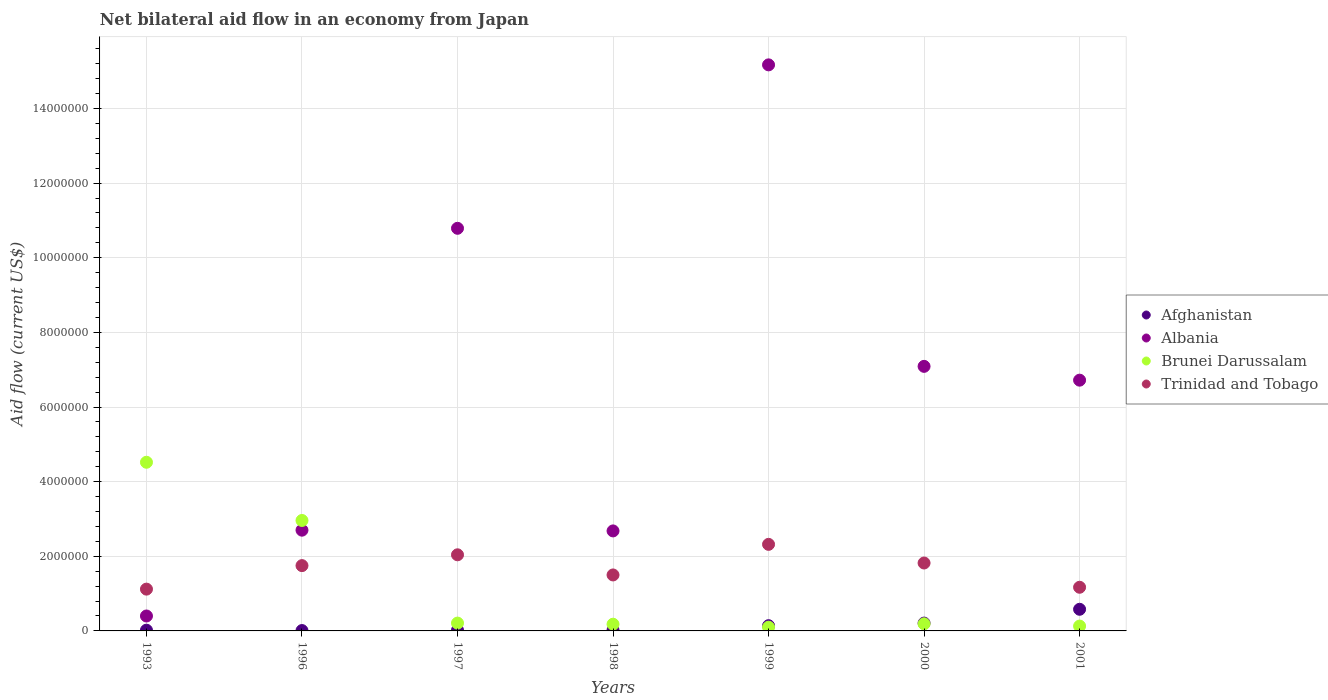How many different coloured dotlines are there?
Offer a terse response. 4. What is the net bilateral aid flow in Albania in 1998?
Make the answer very short. 2.68e+06. Across all years, what is the maximum net bilateral aid flow in Afghanistan?
Your response must be concise. 5.80e+05. In which year was the net bilateral aid flow in Trinidad and Tobago maximum?
Provide a short and direct response. 1999. In which year was the net bilateral aid flow in Trinidad and Tobago minimum?
Your answer should be compact. 1993. What is the total net bilateral aid flow in Afghanistan in the graph?
Give a very brief answer. 1.00e+06. What is the difference between the net bilateral aid flow in Albania in 1993 and that in 2001?
Provide a succinct answer. -6.32e+06. What is the difference between the net bilateral aid flow in Albania in 1999 and the net bilateral aid flow in Afghanistan in 1996?
Give a very brief answer. 1.52e+07. What is the average net bilateral aid flow in Trinidad and Tobago per year?
Keep it short and to the point. 1.67e+06. In the year 1997, what is the difference between the net bilateral aid flow in Trinidad and Tobago and net bilateral aid flow in Afghanistan?
Your answer should be compact. 2.02e+06. In how many years, is the net bilateral aid flow in Trinidad and Tobago greater than 4400000 US$?
Provide a succinct answer. 0. What is the ratio of the net bilateral aid flow in Brunei Darussalam in 1997 to that in 1999?
Give a very brief answer. 2.1. Is the net bilateral aid flow in Afghanistan in 1993 less than that in 1996?
Provide a succinct answer. No. Is the difference between the net bilateral aid flow in Trinidad and Tobago in 1998 and 2001 greater than the difference between the net bilateral aid flow in Afghanistan in 1998 and 2001?
Offer a very short reply. Yes. What is the difference between the highest and the second highest net bilateral aid flow in Afghanistan?
Offer a very short reply. 3.70e+05. What is the difference between the highest and the lowest net bilateral aid flow in Brunei Darussalam?
Offer a terse response. 4.42e+06. Is the sum of the net bilateral aid flow in Trinidad and Tobago in 1998 and 2000 greater than the maximum net bilateral aid flow in Albania across all years?
Ensure brevity in your answer.  No. Is it the case that in every year, the sum of the net bilateral aid flow in Albania and net bilateral aid flow in Brunei Darussalam  is greater than the sum of net bilateral aid flow in Afghanistan and net bilateral aid flow in Trinidad and Tobago?
Make the answer very short. Yes. Is it the case that in every year, the sum of the net bilateral aid flow in Brunei Darussalam and net bilateral aid flow in Albania  is greater than the net bilateral aid flow in Trinidad and Tobago?
Give a very brief answer. Yes. Does the net bilateral aid flow in Trinidad and Tobago monotonically increase over the years?
Offer a very short reply. No. Is the net bilateral aid flow in Trinidad and Tobago strictly less than the net bilateral aid flow in Afghanistan over the years?
Make the answer very short. No. What is the difference between two consecutive major ticks on the Y-axis?
Offer a terse response. 2.00e+06. Does the graph contain any zero values?
Give a very brief answer. No. How many legend labels are there?
Offer a terse response. 4. What is the title of the graph?
Offer a very short reply. Net bilateral aid flow in an economy from Japan. What is the label or title of the X-axis?
Offer a very short reply. Years. What is the label or title of the Y-axis?
Provide a succinct answer. Aid flow (current US$). What is the Aid flow (current US$) in Albania in 1993?
Provide a succinct answer. 4.00e+05. What is the Aid flow (current US$) of Brunei Darussalam in 1993?
Make the answer very short. 4.52e+06. What is the Aid flow (current US$) of Trinidad and Tobago in 1993?
Make the answer very short. 1.12e+06. What is the Aid flow (current US$) in Afghanistan in 1996?
Your answer should be very brief. 10000. What is the Aid flow (current US$) of Albania in 1996?
Your response must be concise. 2.70e+06. What is the Aid flow (current US$) in Brunei Darussalam in 1996?
Make the answer very short. 2.96e+06. What is the Aid flow (current US$) of Trinidad and Tobago in 1996?
Ensure brevity in your answer.  1.75e+06. What is the Aid flow (current US$) in Albania in 1997?
Give a very brief answer. 1.08e+07. What is the Aid flow (current US$) in Trinidad and Tobago in 1997?
Offer a very short reply. 2.04e+06. What is the Aid flow (current US$) in Afghanistan in 1998?
Keep it short and to the point. 2.00e+04. What is the Aid flow (current US$) of Albania in 1998?
Provide a succinct answer. 2.68e+06. What is the Aid flow (current US$) in Brunei Darussalam in 1998?
Offer a terse response. 1.80e+05. What is the Aid flow (current US$) of Trinidad and Tobago in 1998?
Offer a very short reply. 1.50e+06. What is the Aid flow (current US$) in Albania in 1999?
Give a very brief answer. 1.52e+07. What is the Aid flow (current US$) of Brunei Darussalam in 1999?
Your response must be concise. 1.00e+05. What is the Aid flow (current US$) of Trinidad and Tobago in 1999?
Offer a terse response. 2.32e+06. What is the Aid flow (current US$) of Albania in 2000?
Keep it short and to the point. 7.09e+06. What is the Aid flow (current US$) of Trinidad and Tobago in 2000?
Keep it short and to the point. 1.82e+06. What is the Aid flow (current US$) in Afghanistan in 2001?
Your answer should be very brief. 5.80e+05. What is the Aid flow (current US$) in Albania in 2001?
Provide a succinct answer. 6.72e+06. What is the Aid flow (current US$) in Brunei Darussalam in 2001?
Give a very brief answer. 1.30e+05. What is the Aid flow (current US$) in Trinidad and Tobago in 2001?
Offer a terse response. 1.17e+06. Across all years, what is the maximum Aid flow (current US$) of Afghanistan?
Ensure brevity in your answer.  5.80e+05. Across all years, what is the maximum Aid flow (current US$) of Albania?
Provide a short and direct response. 1.52e+07. Across all years, what is the maximum Aid flow (current US$) of Brunei Darussalam?
Your answer should be compact. 4.52e+06. Across all years, what is the maximum Aid flow (current US$) in Trinidad and Tobago?
Ensure brevity in your answer.  2.32e+06. Across all years, what is the minimum Aid flow (current US$) in Afghanistan?
Provide a succinct answer. 10000. Across all years, what is the minimum Aid flow (current US$) of Albania?
Make the answer very short. 4.00e+05. Across all years, what is the minimum Aid flow (current US$) in Brunei Darussalam?
Give a very brief answer. 1.00e+05. Across all years, what is the minimum Aid flow (current US$) in Trinidad and Tobago?
Offer a terse response. 1.12e+06. What is the total Aid flow (current US$) of Albania in the graph?
Provide a succinct answer. 4.56e+07. What is the total Aid flow (current US$) in Brunei Darussalam in the graph?
Provide a short and direct response. 8.29e+06. What is the total Aid flow (current US$) of Trinidad and Tobago in the graph?
Give a very brief answer. 1.17e+07. What is the difference between the Aid flow (current US$) of Albania in 1993 and that in 1996?
Provide a short and direct response. -2.30e+06. What is the difference between the Aid flow (current US$) in Brunei Darussalam in 1993 and that in 1996?
Give a very brief answer. 1.56e+06. What is the difference between the Aid flow (current US$) in Trinidad and Tobago in 1993 and that in 1996?
Your answer should be very brief. -6.30e+05. What is the difference between the Aid flow (current US$) of Albania in 1993 and that in 1997?
Your response must be concise. -1.04e+07. What is the difference between the Aid flow (current US$) of Brunei Darussalam in 1993 and that in 1997?
Your answer should be compact. 4.31e+06. What is the difference between the Aid flow (current US$) of Trinidad and Tobago in 1993 and that in 1997?
Ensure brevity in your answer.  -9.20e+05. What is the difference between the Aid flow (current US$) of Afghanistan in 1993 and that in 1998?
Offer a terse response. 0. What is the difference between the Aid flow (current US$) of Albania in 1993 and that in 1998?
Offer a very short reply. -2.28e+06. What is the difference between the Aid flow (current US$) of Brunei Darussalam in 1993 and that in 1998?
Offer a terse response. 4.34e+06. What is the difference between the Aid flow (current US$) of Trinidad and Tobago in 1993 and that in 1998?
Your answer should be compact. -3.80e+05. What is the difference between the Aid flow (current US$) in Albania in 1993 and that in 1999?
Your answer should be compact. -1.48e+07. What is the difference between the Aid flow (current US$) of Brunei Darussalam in 1993 and that in 1999?
Your answer should be compact. 4.42e+06. What is the difference between the Aid flow (current US$) in Trinidad and Tobago in 1993 and that in 1999?
Give a very brief answer. -1.20e+06. What is the difference between the Aid flow (current US$) of Afghanistan in 1993 and that in 2000?
Offer a very short reply. -1.90e+05. What is the difference between the Aid flow (current US$) in Albania in 1993 and that in 2000?
Your answer should be very brief. -6.69e+06. What is the difference between the Aid flow (current US$) of Brunei Darussalam in 1993 and that in 2000?
Ensure brevity in your answer.  4.33e+06. What is the difference between the Aid flow (current US$) in Trinidad and Tobago in 1993 and that in 2000?
Ensure brevity in your answer.  -7.00e+05. What is the difference between the Aid flow (current US$) of Afghanistan in 1993 and that in 2001?
Provide a succinct answer. -5.60e+05. What is the difference between the Aid flow (current US$) of Albania in 1993 and that in 2001?
Keep it short and to the point. -6.32e+06. What is the difference between the Aid flow (current US$) of Brunei Darussalam in 1993 and that in 2001?
Make the answer very short. 4.39e+06. What is the difference between the Aid flow (current US$) in Trinidad and Tobago in 1993 and that in 2001?
Provide a short and direct response. -5.00e+04. What is the difference between the Aid flow (current US$) of Albania in 1996 and that in 1997?
Offer a very short reply. -8.09e+06. What is the difference between the Aid flow (current US$) of Brunei Darussalam in 1996 and that in 1997?
Your answer should be very brief. 2.75e+06. What is the difference between the Aid flow (current US$) of Albania in 1996 and that in 1998?
Make the answer very short. 2.00e+04. What is the difference between the Aid flow (current US$) in Brunei Darussalam in 1996 and that in 1998?
Make the answer very short. 2.78e+06. What is the difference between the Aid flow (current US$) in Albania in 1996 and that in 1999?
Ensure brevity in your answer.  -1.25e+07. What is the difference between the Aid flow (current US$) of Brunei Darussalam in 1996 and that in 1999?
Your answer should be very brief. 2.86e+06. What is the difference between the Aid flow (current US$) of Trinidad and Tobago in 1996 and that in 1999?
Make the answer very short. -5.70e+05. What is the difference between the Aid flow (current US$) in Afghanistan in 1996 and that in 2000?
Ensure brevity in your answer.  -2.00e+05. What is the difference between the Aid flow (current US$) in Albania in 1996 and that in 2000?
Offer a very short reply. -4.39e+06. What is the difference between the Aid flow (current US$) of Brunei Darussalam in 1996 and that in 2000?
Keep it short and to the point. 2.77e+06. What is the difference between the Aid flow (current US$) of Trinidad and Tobago in 1996 and that in 2000?
Your answer should be very brief. -7.00e+04. What is the difference between the Aid flow (current US$) in Afghanistan in 1996 and that in 2001?
Your answer should be compact. -5.70e+05. What is the difference between the Aid flow (current US$) of Albania in 1996 and that in 2001?
Your answer should be compact. -4.02e+06. What is the difference between the Aid flow (current US$) of Brunei Darussalam in 1996 and that in 2001?
Provide a succinct answer. 2.83e+06. What is the difference between the Aid flow (current US$) in Trinidad and Tobago in 1996 and that in 2001?
Ensure brevity in your answer.  5.80e+05. What is the difference between the Aid flow (current US$) of Albania in 1997 and that in 1998?
Keep it short and to the point. 8.11e+06. What is the difference between the Aid flow (current US$) of Brunei Darussalam in 1997 and that in 1998?
Make the answer very short. 3.00e+04. What is the difference between the Aid flow (current US$) of Trinidad and Tobago in 1997 and that in 1998?
Your response must be concise. 5.40e+05. What is the difference between the Aid flow (current US$) in Albania in 1997 and that in 1999?
Make the answer very short. -4.38e+06. What is the difference between the Aid flow (current US$) in Brunei Darussalam in 1997 and that in 1999?
Provide a succinct answer. 1.10e+05. What is the difference between the Aid flow (current US$) of Trinidad and Tobago in 1997 and that in 1999?
Provide a succinct answer. -2.80e+05. What is the difference between the Aid flow (current US$) of Albania in 1997 and that in 2000?
Give a very brief answer. 3.70e+06. What is the difference between the Aid flow (current US$) in Trinidad and Tobago in 1997 and that in 2000?
Your answer should be compact. 2.20e+05. What is the difference between the Aid flow (current US$) in Afghanistan in 1997 and that in 2001?
Your answer should be very brief. -5.60e+05. What is the difference between the Aid flow (current US$) in Albania in 1997 and that in 2001?
Provide a succinct answer. 4.07e+06. What is the difference between the Aid flow (current US$) in Trinidad and Tobago in 1997 and that in 2001?
Offer a very short reply. 8.70e+05. What is the difference between the Aid flow (current US$) in Afghanistan in 1998 and that in 1999?
Your response must be concise. -1.20e+05. What is the difference between the Aid flow (current US$) of Albania in 1998 and that in 1999?
Offer a terse response. -1.25e+07. What is the difference between the Aid flow (current US$) in Trinidad and Tobago in 1998 and that in 1999?
Your answer should be compact. -8.20e+05. What is the difference between the Aid flow (current US$) in Afghanistan in 1998 and that in 2000?
Offer a very short reply. -1.90e+05. What is the difference between the Aid flow (current US$) of Albania in 1998 and that in 2000?
Provide a short and direct response. -4.41e+06. What is the difference between the Aid flow (current US$) in Trinidad and Tobago in 1998 and that in 2000?
Offer a terse response. -3.20e+05. What is the difference between the Aid flow (current US$) in Afghanistan in 1998 and that in 2001?
Ensure brevity in your answer.  -5.60e+05. What is the difference between the Aid flow (current US$) of Albania in 1998 and that in 2001?
Provide a short and direct response. -4.04e+06. What is the difference between the Aid flow (current US$) in Trinidad and Tobago in 1998 and that in 2001?
Give a very brief answer. 3.30e+05. What is the difference between the Aid flow (current US$) in Albania in 1999 and that in 2000?
Offer a very short reply. 8.08e+06. What is the difference between the Aid flow (current US$) of Brunei Darussalam in 1999 and that in 2000?
Your answer should be very brief. -9.00e+04. What is the difference between the Aid flow (current US$) of Trinidad and Tobago in 1999 and that in 2000?
Provide a succinct answer. 5.00e+05. What is the difference between the Aid flow (current US$) in Afghanistan in 1999 and that in 2001?
Ensure brevity in your answer.  -4.40e+05. What is the difference between the Aid flow (current US$) in Albania in 1999 and that in 2001?
Your answer should be very brief. 8.45e+06. What is the difference between the Aid flow (current US$) of Brunei Darussalam in 1999 and that in 2001?
Your answer should be compact. -3.00e+04. What is the difference between the Aid flow (current US$) in Trinidad and Tobago in 1999 and that in 2001?
Your answer should be compact. 1.15e+06. What is the difference between the Aid flow (current US$) of Afghanistan in 2000 and that in 2001?
Keep it short and to the point. -3.70e+05. What is the difference between the Aid flow (current US$) in Trinidad and Tobago in 2000 and that in 2001?
Ensure brevity in your answer.  6.50e+05. What is the difference between the Aid flow (current US$) of Afghanistan in 1993 and the Aid flow (current US$) of Albania in 1996?
Give a very brief answer. -2.68e+06. What is the difference between the Aid flow (current US$) in Afghanistan in 1993 and the Aid flow (current US$) in Brunei Darussalam in 1996?
Give a very brief answer. -2.94e+06. What is the difference between the Aid flow (current US$) of Afghanistan in 1993 and the Aid flow (current US$) of Trinidad and Tobago in 1996?
Make the answer very short. -1.73e+06. What is the difference between the Aid flow (current US$) of Albania in 1993 and the Aid flow (current US$) of Brunei Darussalam in 1996?
Offer a terse response. -2.56e+06. What is the difference between the Aid flow (current US$) in Albania in 1993 and the Aid flow (current US$) in Trinidad and Tobago in 1996?
Your answer should be very brief. -1.35e+06. What is the difference between the Aid flow (current US$) of Brunei Darussalam in 1993 and the Aid flow (current US$) of Trinidad and Tobago in 1996?
Provide a succinct answer. 2.77e+06. What is the difference between the Aid flow (current US$) in Afghanistan in 1993 and the Aid flow (current US$) in Albania in 1997?
Make the answer very short. -1.08e+07. What is the difference between the Aid flow (current US$) in Afghanistan in 1993 and the Aid flow (current US$) in Brunei Darussalam in 1997?
Keep it short and to the point. -1.90e+05. What is the difference between the Aid flow (current US$) of Afghanistan in 1993 and the Aid flow (current US$) of Trinidad and Tobago in 1997?
Offer a terse response. -2.02e+06. What is the difference between the Aid flow (current US$) of Albania in 1993 and the Aid flow (current US$) of Brunei Darussalam in 1997?
Make the answer very short. 1.90e+05. What is the difference between the Aid flow (current US$) in Albania in 1993 and the Aid flow (current US$) in Trinidad and Tobago in 1997?
Offer a very short reply. -1.64e+06. What is the difference between the Aid flow (current US$) in Brunei Darussalam in 1993 and the Aid flow (current US$) in Trinidad and Tobago in 1997?
Make the answer very short. 2.48e+06. What is the difference between the Aid flow (current US$) in Afghanistan in 1993 and the Aid flow (current US$) in Albania in 1998?
Keep it short and to the point. -2.66e+06. What is the difference between the Aid flow (current US$) of Afghanistan in 1993 and the Aid flow (current US$) of Trinidad and Tobago in 1998?
Offer a terse response. -1.48e+06. What is the difference between the Aid flow (current US$) in Albania in 1993 and the Aid flow (current US$) in Brunei Darussalam in 1998?
Provide a succinct answer. 2.20e+05. What is the difference between the Aid flow (current US$) in Albania in 1993 and the Aid flow (current US$) in Trinidad and Tobago in 1998?
Offer a terse response. -1.10e+06. What is the difference between the Aid flow (current US$) in Brunei Darussalam in 1993 and the Aid flow (current US$) in Trinidad and Tobago in 1998?
Provide a short and direct response. 3.02e+06. What is the difference between the Aid flow (current US$) in Afghanistan in 1993 and the Aid flow (current US$) in Albania in 1999?
Keep it short and to the point. -1.52e+07. What is the difference between the Aid flow (current US$) in Afghanistan in 1993 and the Aid flow (current US$) in Brunei Darussalam in 1999?
Provide a succinct answer. -8.00e+04. What is the difference between the Aid flow (current US$) in Afghanistan in 1993 and the Aid flow (current US$) in Trinidad and Tobago in 1999?
Offer a very short reply. -2.30e+06. What is the difference between the Aid flow (current US$) in Albania in 1993 and the Aid flow (current US$) in Trinidad and Tobago in 1999?
Offer a terse response. -1.92e+06. What is the difference between the Aid flow (current US$) in Brunei Darussalam in 1993 and the Aid flow (current US$) in Trinidad and Tobago in 1999?
Provide a succinct answer. 2.20e+06. What is the difference between the Aid flow (current US$) in Afghanistan in 1993 and the Aid flow (current US$) in Albania in 2000?
Offer a terse response. -7.07e+06. What is the difference between the Aid flow (current US$) in Afghanistan in 1993 and the Aid flow (current US$) in Brunei Darussalam in 2000?
Provide a succinct answer. -1.70e+05. What is the difference between the Aid flow (current US$) of Afghanistan in 1993 and the Aid flow (current US$) of Trinidad and Tobago in 2000?
Your response must be concise. -1.80e+06. What is the difference between the Aid flow (current US$) in Albania in 1993 and the Aid flow (current US$) in Trinidad and Tobago in 2000?
Your answer should be compact. -1.42e+06. What is the difference between the Aid flow (current US$) of Brunei Darussalam in 1993 and the Aid flow (current US$) of Trinidad and Tobago in 2000?
Your response must be concise. 2.70e+06. What is the difference between the Aid flow (current US$) of Afghanistan in 1993 and the Aid flow (current US$) of Albania in 2001?
Provide a short and direct response. -6.70e+06. What is the difference between the Aid flow (current US$) of Afghanistan in 1993 and the Aid flow (current US$) of Trinidad and Tobago in 2001?
Offer a terse response. -1.15e+06. What is the difference between the Aid flow (current US$) in Albania in 1993 and the Aid flow (current US$) in Brunei Darussalam in 2001?
Keep it short and to the point. 2.70e+05. What is the difference between the Aid flow (current US$) of Albania in 1993 and the Aid flow (current US$) of Trinidad and Tobago in 2001?
Make the answer very short. -7.70e+05. What is the difference between the Aid flow (current US$) of Brunei Darussalam in 1993 and the Aid flow (current US$) of Trinidad and Tobago in 2001?
Your answer should be very brief. 3.35e+06. What is the difference between the Aid flow (current US$) in Afghanistan in 1996 and the Aid flow (current US$) in Albania in 1997?
Give a very brief answer. -1.08e+07. What is the difference between the Aid flow (current US$) in Afghanistan in 1996 and the Aid flow (current US$) in Trinidad and Tobago in 1997?
Give a very brief answer. -2.03e+06. What is the difference between the Aid flow (current US$) of Albania in 1996 and the Aid flow (current US$) of Brunei Darussalam in 1997?
Ensure brevity in your answer.  2.49e+06. What is the difference between the Aid flow (current US$) in Brunei Darussalam in 1996 and the Aid flow (current US$) in Trinidad and Tobago in 1997?
Keep it short and to the point. 9.20e+05. What is the difference between the Aid flow (current US$) in Afghanistan in 1996 and the Aid flow (current US$) in Albania in 1998?
Your answer should be very brief. -2.67e+06. What is the difference between the Aid flow (current US$) in Afghanistan in 1996 and the Aid flow (current US$) in Brunei Darussalam in 1998?
Your response must be concise. -1.70e+05. What is the difference between the Aid flow (current US$) of Afghanistan in 1996 and the Aid flow (current US$) of Trinidad and Tobago in 1998?
Keep it short and to the point. -1.49e+06. What is the difference between the Aid flow (current US$) of Albania in 1996 and the Aid flow (current US$) of Brunei Darussalam in 1998?
Offer a very short reply. 2.52e+06. What is the difference between the Aid flow (current US$) in Albania in 1996 and the Aid flow (current US$) in Trinidad and Tobago in 1998?
Keep it short and to the point. 1.20e+06. What is the difference between the Aid flow (current US$) of Brunei Darussalam in 1996 and the Aid flow (current US$) of Trinidad and Tobago in 1998?
Offer a very short reply. 1.46e+06. What is the difference between the Aid flow (current US$) in Afghanistan in 1996 and the Aid flow (current US$) in Albania in 1999?
Your answer should be compact. -1.52e+07. What is the difference between the Aid flow (current US$) in Afghanistan in 1996 and the Aid flow (current US$) in Brunei Darussalam in 1999?
Your answer should be compact. -9.00e+04. What is the difference between the Aid flow (current US$) in Afghanistan in 1996 and the Aid flow (current US$) in Trinidad and Tobago in 1999?
Your response must be concise. -2.31e+06. What is the difference between the Aid flow (current US$) in Albania in 1996 and the Aid flow (current US$) in Brunei Darussalam in 1999?
Offer a very short reply. 2.60e+06. What is the difference between the Aid flow (current US$) of Brunei Darussalam in 1996 and the Aid flow (current US$) of Trinidad and Tobago in 1999?
Provide a short and direct response. 6.40e+05. What is the difference between the Aid flow (current US$) of Afghanistan in 1996 and the Aid flow (current US$) of Albania in 2000?
Your response must be concise. -7.08e+06. What is the difference between the Aid flow (current US$) of Afghanistan in 1996 and the Aid flow (current US$) of Brunei Darussalam in 2000?
Give a very brief answer. -1.80e+05. What is the difference between the Aid flow (current US$) of Afghanistan in 1996 and the Aid flow (current US$) of Trinidad and Tobago in 2000?
Give a very brief answer. -1.81e+06. What is the difference between the Aid flow (current US$) in Albania in 1996 and the Aid flow (current US$) in Brunei Darussalam in 2000?
Your answer should be very brief. 2.51e+06. What is the difference between the Aid flow (current US$) of Albania in 1996 and the Aid flow (current US$) of Trinidad and Tobago in 2000?
Ensure brevity in your answer.  8.80e+05. What is the difference between the Aid flow (current US$) of Brunei Darussalam in 1996 and the Aid flow (current US$) of Trinidad and Tobago in 2000?
Your answer should be compact. 1.14e+06. What is the difference between the Aid flow (current US$) in Afghanistan in 1996 and the Aid flow (current US$) in Albania in 2001?
Ensure brevity in your answer.  -6.71e+06. What is the difference between the Aid flow (current US$) in Afghanistan in 1996 and the Aid flow (current US$) in Brunei Darussalam in 2001?
Your answer should be very brief. -1.20e+05. What is the difference between the Aid flow (current US$) of Afghanistan in 1996 and the Aid flow (current US$) of Trinidad and Tobago in 2001?
Provide a short and direct response. -1.16e+06. What is the difference between the Aid flow (current US$) in Albania in 1996 and the Aid flow (current US$) in Brunei Darussalam in 2001?
Keep it short and to the point. 2.57e+06. What is the difference between the Aid flow (current US$) of Albania in 1996 and the Aid flow (current US$) of Trinidad and Tobago in 2001?
Your answer should be compact. 1.53e+06. What is the difference between the Aid flow (current US$) of Brunei Darussalam in 1996 and the Aid flow (current US$) of Trinidad and Tobago in 2001?
Ensure brevity in your answer.  1.79e+06. What is the difference between the Aid flow (current US$) of Afghanistan in 1997 and the Aid flow (current US$) of Albania in 1998?
Ensure brevity in your answer.  -2.66e+06. What is the difference between the Aid flow (current US$) in Afghanistan in 1997 and the Aid flow (current US$) in Brunei Darussalam in 1998?
Offer a very short reply. -1.60e+05. What is the difference between the Aid flow (current US$) of Afghanistan in 1997 and the Aid flow (current US$) of Trinidad and Tobago in 1998?
Provide a short and direct response. -1.48e+06. What is the difference between the Aid flow (current US$) of Albania in 1997 and the Aid flow (current US$) of Brunei Darussalam in 1998?
Provide a short and direct response. 1.06e+07. What is the difference between the Aid flow (current US$) of Albania in 1997 and the Aid flow (current US$) of Trinidad and Tobago in 1998?
Offer a terse response. 9.29e+06. What is the difference between the Aid flow (current US$) of Brunei Darussalam in 1997 and the Aid flow (current US$) of Trinidad and Tobago in 1998?
Keep it short and to the point. -1.29e+06. What is the difference between the Aid flow (current US$) of Afghanistan in 1997 and the Aid flow (current US$) of Albania in 1999?
Your response must be concise. -1.52e+07. What is the difference between the Aid flow (current US$) of Afghanistan in 1997 and the Aid flow (current US$) of Brunei Darussalam in 1999?
Ensure brevity in your answer.  -8.00e+04. What is the difference between the Aid flow (current US$) of Afghanistan in 1997 and the Aid flow (current US$) of Trinidad and Tobago in 1999?
Keep it short and to the point. -2.30e+06. What is the difference between the Aid flow (current US$) in Albania in 1997 and the Aid flow (current US$) in Brunei Darussalam in 1999?
Your answer should be compact. 1.07e+07. What is the difference between the Aid flow (current US$) in Albania in 1997 and the Aid flow (current US$) in Trinidad and Tobago in 1999?
Your response must be concise. 8.47e+06. What is the difference between the Aid flow (current US$) of Brunei Darussalam in 1997 and the Aid flow (current US$) of Trinidad and Tobago in 1999?
Your answer should be very brief. -2.11e+06. What is the difference between the Aid flow (current US$) of Afghanistan in 1997 and the Aid flow (current US$) of Albania in 2000?
Keep it short and to the point. -7.07e+06. What is the difference between the Aid flow (current US$) in Afghanistan in 1997 and the Aid flow (current US$) in Brunei Darussalam in 2000?
Your answer should be compact. -1.70e+05. What is the difference between the Aid flow (current US$) in Afghanistan in 1997 and the Aid flow (current US$) in Trinidad and Tobago in 2000?
Your answer should be very brief. -1.80e+06. What is the difference between the Aid flow (current US$) of Albania in 1997 and the Aid flow (current US$) of Brunei Darussalam in 2000?
Your answer should be very brief. 1.06e+07. What is the difference between the Aid flow (current US$) of Albania in 1997 and the Aid flow (current US$) of Trinidad and Tobago in 2000?
Provide a short and direct response. 8.97e+06. What is the difference between the Aid flow (current US$) in Brunei Darussalam in 1997 and the Aid flow (current US$) in Trinidad and Tobago in 2000?
Give a very brief answer. -1.61e+06. What is the difference between the Aid flow (current US$) of Afghanistan in 1997 and the Aid flow (current US$) of Albania in 2001?
Ensure brevity in your answer.  -6.70e+06. What is the difference between the Aid flow (current US$) of Afghanistan in 1997 and the Aid flow (current US$) of Brunei Darussalam in 2001?
Your response must be concise. -1.10e+05. What is the difference between the Aid flow (current US$) of Afghanistan in 1997 and the Aid flow (current US$) of Trinidad and Tobago in 2001?
Offer a terse response. -1.15e+06. What is the difference between the Aid flow (current US$) of Albania in 1997 and the Aid flow (current US$) of Brunei Darussalam in 2001?
Offer a terse response. 1.07e+07. What is the difference between the Aid flow (current US$) of Albania in 1997 and the Aid flow (current US$) of Trinidad and Tobago in 2001?
Offer a very short reply. 9.62e+06. What is the difference between the Aid flow (current US$) in Brunei Darussalam in 1997 and the Aid flow (current US$) in Trinidad and Tobago in 2001?
Keep it short and to the point. -9.60e+05. What is the difference between the Aid flow (current US$) in Afghanistan in 1998 and the Aid flow (current US$) in Albania in 1999?
Your response must be concise. -1.52e+07. What is the difference between the Aid flow (current US$) in Afghanistan in 1998 and the Aid flow (current US$) in Trinidad and Tobago in 1999?
Your answer should be very brief. -2.30e+06. What is the difference between the Aid flow (current US$) of Albania in 1998 and the Aid flow (current US$) of Brunei Darussalam in 1999?
Provide a short and direct response. 2.58e+06. What is the difference between the Aid flow (current US$) in Brunei Darussalam in 1998 and the Aid flow (current US$) in Trinidad and Tobago in 1999?
Your answer should be compact. -2.14e+06. What is the difference between the Aid flow (current US$) in Afghanistan in 1998 and the Aid flow (current US$) in Albania in 2000?
Keep it short and to the point. -7.07e+06. What is the difference between the Aid flow (current US$) of Afghanistan in 1998 and the Aid flow (current US$) of Trinidad and Tobago in 2000?
Ensure brevity in your answer.  -1.80e+06. What is the difference between the Aid flow (current US$) in Albania in 1998 and the Aid flow (current US$) in Brunei Darussalam in 2000?
Offer a terse response. 2.49e+06. What is the difference between the Aid flow (current US$) in Albania in 1998 and the Aid flow (current US$) in Trinidad and Tobago in 2000?
Offer a very short reply. 8.60e+05. What is the difference between the Aid flow (current US$) of Brunei Darussalam in 1998 and the Aid flow (current US$) of Trinidad and Tobago in 2000?
Your answer should be very brief. -1.64e+06. What is the difference between the Aid flow (current US$) in Afghanistan in 1998 and the Aid flow (current US$) in Albania in 2001?
Offer a very short reply. -6.70e+06. What is the difference between the Aid flow (current US$) of Afghanistan in 1998 and the Aid flow (current US$) of Brunei Darussalam in 2001?
Your response must be concise. -1.10e+05. What is the difference between the Aid flow (current US$) in Afghanistan in 1998 and the Aid flow (current US$) in Trinidad and Tobago in 2001?
Keep it short and to the point. -1.15e+06. What is the difference between the Aid flow (current US$) in Albania in 1998 and the Aid flow (current US$) in Brunei Darussalam in 2001?
Provide a succinct answer. 2.55e+06. What is the difference between the Aid flow (current US$) in Albania in 1998 and the Aid flow (current US$) in Trinidad and Tobago in 2001?
Give a very brief answer. 1.51e+06. What is the difference between the Aid flow (current US$) in Brunei Darussalam in 1998 and the Aid flow (current US$) in Trinidad and Tobago in 2001?
Ensure brevity in your answer.  -9.90e+05. What is the difference between the Aid flow (current US$) of Afghanistan in 1999 and the Aid flow (current US$) of Albania in 2000?
Offer a very short reply. -6.95e+06. What is the difference between the Aid flow (current US$) in Afghanistan in 1999 and the Aid flow (current US$) in Trinidad and Tobago in 2000?
Your answer should be very brief. -1.68e+06. What is the difference between the Aid flow (current US$) of Albania in 1999 and the Aid flow (current US$) of Brunei Darussalam in 2000?
Provide a short and direct response. 1.50e+07. What is the difference between the Aid flow (current US$) of Albania in 1999 and the Aid flow (current US$) of Trinidad and Tobago in 2000?
Give a very brief answer. 1.34e+07. What is the difference between the Aid flow (current US$) in Brunei Darussalam in 1999 and the Aid flow (current US$) in Trinidad and Tobago in 2000?
Provide a short and direct response. -1.72e+06. What is the difference between the Aid flow (current US$) in Afghanistan in 1999 and the Aid flow (current US$) in Albania in 2001?
Your answer should be very brief. -6.58e+06. What is the difference between the Aid flow (current US$) of Afghanistan in 1999 and the Aid flow (current US$) of Trinidad and Tobago in 2001?
Provide a short and direct response. -1.03e+06. What is the difference between the Aid flow (current US$) of Albania in 1999 and the Aid flow (current US$) of Brunei Darussalam in 2001?
Give a very brief answer. 1.50e+07. What is the difference between the Aid flow (current US$) in Albania in 1999 and the Aid flow (current US$) in Trinidad and Tobago in 2001?
Offer a very short reply. 1.40e+07. What is the difference between the Aid flow (current US$) in Brunei Darussalam in 1999 and the Aid flow (current US$) in Trinidad and Tobago in 2001?
Offer a terse response. -1.07e+06. What is the difference between the Aid flow (current US$) of Afghanistan in 2000 and the Aid flow (current US$) of Albania in 2001?
Offer a terse response. -6.51e+06. What is the difference between the Aid flow (current US$) of Afghanistan in 2000 and the Aid flow (current US$) of Brunei Darussalam in 2001?
Ensure brevity in your answer.  8.00e+04. What is the difference between the Aid flow (current US$) in Afghanistan in 2000 and the Aid flow (current US$) in Trinidad and Tobago in 2001?
Offer a very short reply. -9.60e+05. What is the difference between the Aid flow (current US$) in Albania in 2000 and the Aid flow (current US$) in Brunei Darussalam in 2001?
Provide a short and direct response. 6.96e+06. What is the difference between the Aid flow (current US$) in Albania in 2000 and the Aid flow (current US$) in Trinidad and Tobago in 2001?
Give a very brief answer. 5.92e+06. What is the difference between the Aid flow (current US$) of Brunei Darussalam in 2000 and the Aid flow (current US$) of Trinidad and Tobago in 2001?
Your response must be concise. -9.80e+05. What is the average Aid flow (current US$) in Afghanistan per year?
Ensure brevity in your answer.  1.43e+05. What is the average Aid flow (current US$) of Albania per year?
Your answer should be compact. 6.51e+06. What is the average Aid flow (current US$) in Brunei Darussalam per year?
Offer a very short reply. 1.18e+06. What is the average Aid flow (current US$) in Trinidad and Tobago per year?
Offer a very short reply. 1.67e+06. In the year 1993, what is the difference between the Aid flow (current US$) of Afghanistan and Aid flow (current US$) of Albania?
Provide a succinct answer. -3.80e+05. In the year 1993, what is the difference between the Aid flow (current US$) in Afghanistan and Aid flow (current US$) in Brunei Darussalam?
Give a very brief answer. -4.50e+06. In the year 1993, what is the difference between the Aid flow (current US$) of Afghanistan and Aid flow (current US$) of Trinidad and Tobago?
Your answer should be very brief. -1.10e+06. In the year 1993, what is the difference between the Aid flow (current US$) in Albania and Aid flow (current US$) in Brunei Darussalam?
Your answer should be compact. -4.12e+06. In the year 1993, what is the difference between the Aid flow (current US$) of Albania and Aid flow (current US$) of Trinidad and Tobago?
Offer a very short reply. -7.20e+05. In the year 1993, what is the difference between the Aid flow (current US$) in Brunei Darussalam and Aid flow (current US$) in Trinidad and Tobago?
Ensure brevity in your answer.  3.40e+06. In the year 1996, what is the difference between the Aid flow (current US$) in Afghanistan and Aid flow (current US$) in Albania?
Provide a succinct answer. -2.69e+06. In the year 1996, what is the difference between the Aid flow (current US$) in Afghanistan and Aid flow (current US$) in Brunei Darussalam?
Provide a succinct answer. -2.95e+06. In the year 1996, what is the difference between the Aid flow (current US$) in Afghanistan and Aid flow (current US$) in Trinidad and Tobago?
Ensure brevity in your answer.  -1.74e+06. In the year 1996, what is the difference between the Aid flow (current US$) in Albania and Aid flow (current US$) in Trinidad and Tobago?
Your answer should be very brief. 9.50e+05. In the year 1996, what is the difference between the Aid flow (current US$) in Brunei Darussalam and Aid flow (current US$) in Trinidad and Tobago?
Your answer should be very brief. 1.21e+06. In the year 1997, what is the difference between the Aid flow (current US$) in Afghanistan and Aid flow (current US$) in Albania?
Give a very brief answer. -1.08e+07. In the year 1997, what is the difference between the Aid flow (current US$) in Afghanistan and Aid flow (current US$) in Brunei Darussalam?
Your answer should be very brief. -1.90e+05. In the year 1997, what is the difference between the Aid flow (current US$) in Afghanistan and Aid flow (current US$) in Trinidad and Tobago?
Make the answer very short. -2.02e+06. In the year 1997, what is the difference between the Aid flow (current US$) of Albania and Aid flow (current US$) of Brunei Darussalam?
Offer a very short reply. 1.06e+07. In the year 1997, what is the difference between the Aid flow (current US$) of Albania and Aid flow (current US$) of Trinidad and Tobago?
Make the answer very short. 8.75e+06. In the year 1997, what is the difference between the Aid flow (current US$) of Brunei Darussalam and Aid flow (current US$) of Trinidad and Tobago?
Ensure brevity in your answer.  -1.83e+06. In the year 1998, what is the difference between the Aid flow (current US$) of Afghanistan and Aid flow (current US$) of Albania?
Offer a terse response. -2.66e+06. In the year 1998, what is the difference between the Aid flow (current US$) of Afghanistan and Aid flow (current US$) of Trinidad and Tobago?
Offer a very short reply. -1.48e+06. In the year 1998, what is the difference between the Aid flow (current US$) of Albania and Aid flow (current US$) of Brunei Darussalam?
Your answer should be compact. 2.50e+06. In the year 1998, what is the difference between the Aid flow (current US$) of Albania and Aid flow (current US$) of Trinidad and Tobago?
Offer a terse response. 1.18e+06. In the year 1998, what is the difference between the Aid flow (current US$) of Brunei Darussalam and Aid flow (current US$) of Trinidad and Tobago?
Provide a short and direct response. -1.32e+06. In the year 1999, what is the difference between the Aid flow (current US$) in Afghanistan and Aid flow (current US$) in Albania?
Your response must be concise. -1.50e+07. In the year 1999, what is the difference between the Aid flow (current US$) of Afghanistan and Aid flow (current US$) of Brunei Darussalam?
Keep it short and to the point. 4.00e+04. In the year 1999, what is the difference between the Aid flow (current US$) in Afghanistan and Aid flow (current US$) in Trinidad and Tobago?
Your answer should be compact. -2.18e+06. In the year 1999, what is the difference between the Aid flow (current US$) of Albania and Aid flow (current US$) of Brunei Darussalam?
Offer a very short reply. 1.51e+07. In the year 1999, what is the difference between the Aid flow (current US$) of Albania and Aid flow (current US$) of Trinidad and Tobago?
Offer a terse response. 1.28e+07. In the year 1999, what is the difference between the Aid flow (current US$) in Brunei Darussalam and Aid flow (current US$) in Trinidad and Tobago?
Your answer should be very brief. -2.22e+06. In the year 2000, what is the difference between the Aid flow (current US$) of Afghanistan and Aid flow (current US$) of Albania?
Offer a terse response. -6.88e+06. In the year 2000, what is the difference between the Aid flow (current US$) of Afghanistan and Aid flow (current US$) of Brunei Darussalam?
Provide a short and direct response. 2.00e+04. In the year 2000, what is the difference between the Aid flow (current US$) of Afghanistan and Aid flow (current US$) of Trinidad and Tobago?
Provide a short and direct response. -1.61e+06. In the year 2000, what is the difference between the Aid flow (current US$) in Albania and Aid flow (current US$) in Brunei Darussalam?
Your answer should be compact. 6.90e+06. In the year 2000, what is the difference between the Aid flow (current US$) of Albania and Aid flow (current US$) of Trinidad and Tobago?
Offer a very short reply. 5.27e+06. In the year 2000, what is the difference between the Aid flow (current US$) in Brunei Darussalam and Aid flow (current US$) in Trinidad and Tobago?
Offer a terse response. -1.63e+06. In the year 2001, what is the difference between the Aid flow (current US$) in Afghanistan and Aid flow (current US$) in Albania?
Your answer should be compact. -6.14e+06. In the year 2001, what is the difference between the Aid flow (current US$) of Afghanistan and Aid flow (current US$) of Trinidad and Tobago?
Ensure brevity in your answer.  -5.90e+05. In the year 2001, what is the difference between the Aid flow (current US$) in Albania and Aid flow (current US$) in Brunei Darussalam?
Offer a terse response. 6.59e+06. In the year 2001, what is the difference between the Aid flow (current US$) in Albania and Aid flow (current US$) in Trinidad and Tobago?
Provide a succinct answer. 5.55e+06. In the year 2001, what is the difference between the Aid flow (current US$) in Brunei Darussalam and Aid flow (current US$) in Trinidad and Tobago?
Ensure brevity in your answer.  -1.04e+06. What is the ratio of the Aid flow (current US$) in Albania in 1993 to that in 1996?
Your answer should be compact. 0.15. What is the ratio of the Aid flow (current US$) in Brunei Darussalam in 1993 to that in 1996?
Offer a terse response. 1.53. What is the ratio of the Aid flow (current US$) of Trinidad and Tobago in 1993 to that in 1996?
Your answer should be very brief. 0.64. What is the ratio of the Aid flow (current US$) in Albania in 1993 to that in 1997?
Keep it short and to the point. 0.04. What is the ratio of the Aid flow (current US$) of Brunei Darussalam in 1993 to that in 1997?
Provide a short and direct response. 21.52. What is the ratio of the Aid flow (current US$) in Trinidad and Tobago in 1993 to that in 1997?
Provide a short and direct response. 0.55. What is the ratio of the Aid flow (current US$) of Albania in 1993 to that in 1998?
Your answer should be compact. 0.15. What is the ratio of the Aid flow (current US$) in Brunei Darussalam in 1993 to that in 1998?
Ensure brevity in your answer.  25.11. What is the ratio of the Aid flow (current US$) in Trinidad and Tobago in 1993 to that in 1998?
Your answer should be compact. 0.75. What is the ratio of the Aid flow (current US$) of Afghanistan in 1993 to that in 1999?
Your response must be concise. 0.14. What is the ratio of the Aid flow (current US$) in Albania in 1993 to that in 1999?
Offer a terse response. 0.03. What is the ratio of the Aid flow (current US$) of Brunei Darussalam in 1993 to that in 1999?
Make the answer very short. 45.2. What is the ratio of the Aid flow (current US$) of Trinidad and Tobago in 1993 to that in 1999?
Ensure brevity in your answer.  0.48. What is the ratio of the Aid flow (current US$) of Afghanistan in 1993 to that in 2000?
Offer a terse response. 0.1. What is the ratio of the Aid flow (current US$) of Albania in 1993 to that in 2000?
Make the answer very short. 0.06. What is the ratio of the Aid flow (current US$) in Brunei Darussalam in 1993 to that in 2000?
Provide a short and direct response. 23.79. What is the ratio of the Aid flow (current US$) of Trinidad and Tobago in 1993 to that in 2000?
Keep it short and to the point. 0.62. What is the ratio of the Aid flow (current US$) in Afghanistan in 1993 to that in 2001?
Offer a very short reply. 0.03. What is the ratio of the Aid flow (current US$) of Albania in 1993 to that in 2001?
Give a very brief answer. 0.06. What is the ratio of the Aid flow (current US$) in Brunei Darussalam in 1993 to that in 2001?
Provide a succinct answer. 34.77. What is the ratio of the Aid flow (current US$) in Trinidad and Tobago in 1993 to that in 2001?
Your answer should be compact. 0.96. What is the ratio of the Aid flow (current US$) in Albania in 1996 to that in 1997?
Offer a very short reply. 0.25. What is the ratio of the Aid flow (current US$) in Brunei Darussalam in 1996 to that in 1997?
Make the answer very short. 14.1. What is the ratio of the Aid flow (current US$) of Trinidad and Tobago in 1996 to that in 1997?
Your response must be concise. 0.86. What is the ratio of the Aid flow (current US$) of Albania in 1996 to that in 1998?
Your answer should be very brief. 1.01. What is the ratio of the Aid flow (current US$) in Brunei Darussalam in 1996 to that in 1998?
Give a very brief answer. 16.44. What is the ratio of the Aid flow (current US$) in Trinidad and Tobago in 1996 to that in 1998?
Your answer should be compact. 1.17. What is the ratio of the Aid flow (current US$) of Afghanistan in 1996 to that in 1999?
Keep it short and to the point. 0.07. What is the ratio of the Aid flow (current US$) in Albania in 1996 to that in 1999?
Offer a terse response. 0.18. What is the ratio of the Aid flow (current US$) in Brunei Darussalam in 1996 to that in 1999?
Provide a short and direct response. 29.6. What is the ratio of the Aid flow (current US$) in Trinidad and Tobago in 1996 to that in 1999?
Give a very brief answer. 0.75. What is the ratio of the Aid flow (current US$) of Afghanistan in 1996 to that in 2000?
Keep it short and to the point. 0.05. What is the ratio of the Aid flow (current US$) of Albania in 1996 to that in 2000?
Your answer should be very brief. 0.38. What is the ratio of the Aid flow (current US$) of Brunei Darussalam in 1996 to that in 2000?
Your response must be concise. 15.58. What is the ratio of the Aid flow (current US$) of Trinidad and Tobago in 1996 to that in 2000?
Keep it short and to the point. 0.96. What is the ratio of the Aid flow (current US$) of Afghanistan in 1996 to that in 2001?
Offer a very short reply. 0.02. What is the ratio of the Aid flow (current US$) of Albania in 1996 to that in 2001?
Provide a succinct answer. 0.4. What is the ratio of the Aid flow (current US$) of Brunei Darussalam in 1996 to that in 2001?
Offer a very short reply. 22.77. What is the ratio of the Aid flow (current US$) in Trinidad and Tobago in 1996 to that in 2001?
Make the answer very short. 1.5. What is the ratio of the Aid flow (current US$) of Albania in 1997 to that in 1998?
Provide a succinct answer. 4.03. What is the ratio of the Aid flow (current US$) of Brunei Darussalam in 1997 to that in 1998?
Give a very brief answer. 1.17. What is the ratio of the Aid flow (current US$) in Trinidad and Tobago in 1997 to that in 1998?
Provide a short and direct response. 1.36. What is the ratio of the Aid flow (current US$) of Afghanistan in 1997 to that in 1999?
Your answer should be very brief. 0.14. What is the ratio of the Aid flow (current US$) of Albania in 1997 to that in 1999?
Make the answer very short. 0.71. What is the ratio of the Aid flow (current US$) of Brunei Darussalam in 1997 to that in 1999?
Your response must be concise. 2.1. What is the ratio of the Aid flow (current US$) of Trinidad and Tobago in 1997 to that in 1999?
Offer a terse response. 0.88. What is the ratio of the Aid flow (current US$) of Afghanistan in 1997 to that in 2000?
Offer a very short reply. 0.1. What is the ratio of the Aid flow (current US$) in Albania in 1997 to that in 2000?
Offer a terse response. 1.52. What is the ratio of the Aid flow (current US$) of Brunei Darussalam in 1997 to that in 2000?
Offer a very short reply. 1.11. What is the ratio of the Aid flow (current US$) in Trinidad and Tobago in 1997 to that in 2000?
Ensure brevity in your answer.  1.12. What is the ratio of the Aid flow (current US$) of Afghanistan in 1997 to that in 2001?
Provide a succinct answer. 0.03. What is the ratio of the Aid flow (current US$) of Albania in 1997 to that in 2001?
Provide a short and direct response. 1.61. What is the ratio of the Aid flow (current US$) in Brunei Darussalam in 1997 to that in 2001?
Offer a very short reply. 1.62. What is the ratio of the Aid flow (current US$) in Trinidad and Tobago in 1997 to that in 2001?
Make the answer very short. 1.74. What is the ratio of the Aid flow (current US$) of Afghanistan in 1998 to that in 1999?
Offer a very short reply. 0.14. What is the ratio of the Aid flow (current US$) in Albania in 1998 to that in 1999?
Provide a short and direct response. 0.18. What is the ratio of the Aid flow (current US$) in Brunei Darussalam in 1998 to that in 1999?
Provide a succinct answer. 1.8. What is the ratio of the Aid flow (current US$) in Trinidad and Tobago in 1998 to that in 1999?
Make the answer very short. 0.65. What is the ratio of the Aid flow (current US$) of Afghanistan in 1998 to that in 2000?
Keep it short and to the point. 0.1. What is the ratio of the Aid flow (current US$) in Albania in 1998 to that in 2000?
Provide a succinct answer. 0.38. What is the ratio of the Aid flow (current US$) in Trinidad and Tobago in 1998 to that in 2000?
Keep it short and to the point. 0.82. What is the ratio of the Aid flow (current US$) in Afghanistan in 1998 to that in 2001?
Give a very brief answer. 0.03. What is the ratio of the Aid flow (current US$) of Albania in 1998 to that in 2001?
Offer a very short reply. 0.4. What is the ratio of the Aid flow (current US$) of Brunei Darussalam in 1998 to that in 2001?
Offer a very short reply. 1.38. What is the ratio of the Aid flow (current US$) in Trinidad and Tobago in 1998 to that in 2001?
Provide a short and direct response. 1.28. What is the ratio of the Aid flow (current US$) in Afghanistan in 1999 to that in 2000?
Keep it short and to the point. 0.67. What is the ratio of the Aid flow (current US$) in Albania in 1999 to that in 2000?
Offer a very short reply. 2.14. What is the ratio of the Aid flow (current US$) in Brunei Darussalam in 1999 to that in 2000?
Keep it short and to the point. 0.53. What is the ratio of the Aid flow (current US$) of Trinidad and Tobago in 1999 to that in 2000?
Make the answer very short. 1.27. What is the ratio of the Aid flow (current US$) of Afghanistan in 1999 to that in 2001?
Your answer should be very brief. 0.24. What is the ratio of the Aid flow (current US$) in Albania in 1999 to that in 2001?
Keep it short and to the point. 2.26. What is the ratio of the Aid flow (current US$) of Brunei Darussalam in 1999 to that in 2001?
Offer a very short reply. 0.77. What is the ratio of the Aid flow (current US$) of Trinidad and Tobago in 1999 to that in 2001?
Your answer should be very brief. 1.98. What is the ratio of the Aid flow (current US$) in Afghanistan in 2000 to that in 2001?
Provide a succinct answer. 0.36. What is the ratio of the Aid flow (current US$) of Albania in 2000 to that in 2001?
Ensure brevity in your answer.  1.06. What is the ratio of the Aid flow (current US$) in Brunei Darussalam in 2000 to that in 2001?
Your response must be concise. 1.46. What is the ratio of the Aid flow (current US$) of Trinidad and Tobago in 2000 to that in 2001?
Your response must be concise. 1.56. What is the difference between the highest and the second highest Aid flow (current US$) of Afghanistan?
Keep it short and to the point. 3.70e+05. What is the difference between the highest and the second highest Aid flow (current US$) in Albania?
Give a very brief answer. 4.38e+06. What is the difference between the highest and the second highest Aid flow (current US$) in Brunei Darussalam?
Offer a very short reply. 1.56e+06. What is the difference between the highest and the second highest Aid flow (current US$) in Trinidad and Tobago?
Ensure brevity in your answer.  2.80e+05. What is the difference between the highest and the lowest Aid flow (current US$) of Afghanistan?
Your answer should be very brief. 5.70e+05. What is the difference between the highest and the lowest Aid flow (current US$) in Albania?
Your answer should be compact. 1.48e+07. What is the difference between the highest and the lowest Aid flow (current US$) of Brunei Darussalam?
Offer a terse response. 4.42e+06. What is the difference between the highest and the lowest Aid flow (current US$) of Trinidad and Tobago?
Your response must be concise. 1.20e+06. 